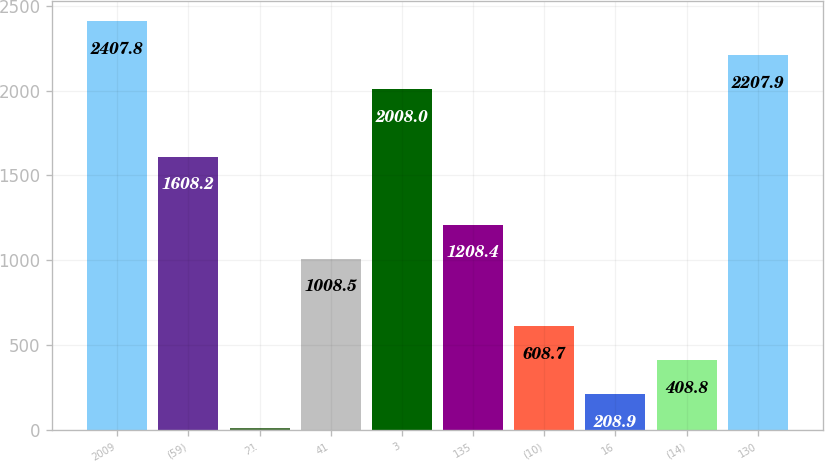Convert chart to OTSL. <chart><loc_0><loc_0><loc_500><loc_500><bar_chart><fcel>2009<fcel>(59)<fcel>21<fcel>41<fcel>3<fcel>135<fcel>(10)<fcel>16<fcel>(14)<fcel>130<nl><fcel>2407.8<fcel>1608.2<fcel>9<fcel>1008.5<fcel>2008<fcel>1208.4<fcel>608.7<fcel>208.9<fcel>408.8<fcel>2207.9<nl></chart> 